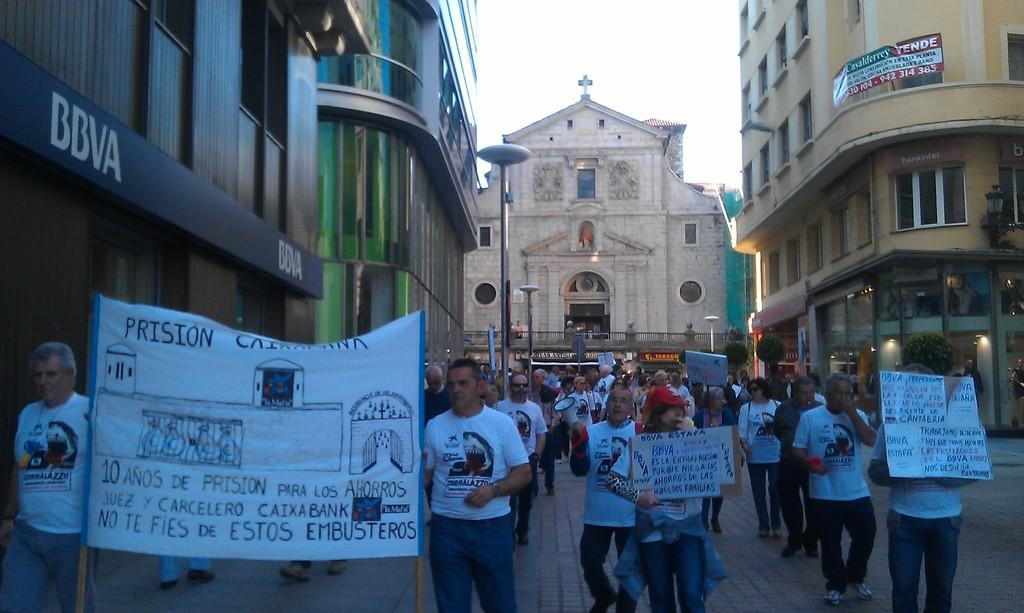How many people are in the group visible in the image? There is a group of people in the image, but the exact number is not specified. What are the people in the group doing? The people are standing in the group are holding a megaphone, a banner, and placards. What can be seen in the background of the image? In the background of the image, there are buildings, lights, poles, trees, and the sky. What type of operation is being performed on the plants in the image? There are no plants present in the image, so no operation is being performed on them. What sign is visible in the image? There is no sign visible in the image; the people are holding a megaphone, a banner, and placards. 